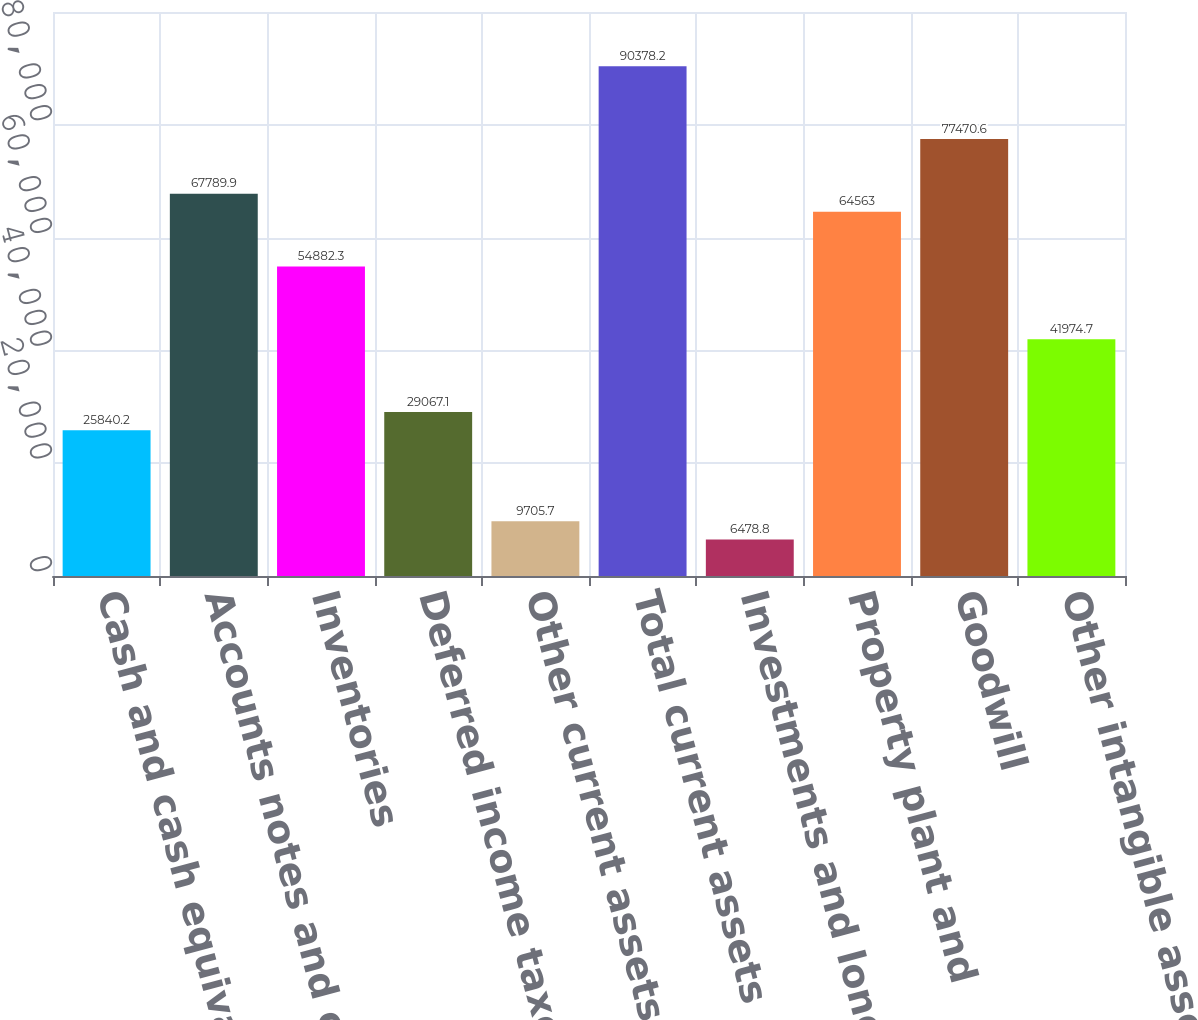<chart> <loc_0><loc_0><loc_500><loc_500><bar_chart><fcel>Cash and cash equivalents<fcel>Accounts notes and other<fcel>Inventories<fcel>Deferred income taxes<fcel>Other current assets<fcel>Total current assets<fcel>Investments and long-term<fcel>Property plant and<fcel>Goodwill<fcel>Other intangible assets-net<nl><fcel>25840.2<fcel>67789.9<fcel>54882.3<fcel>29067.1<fcel>9705.7<fcel>90378.2<fcel>6478.8<fcel>64563<fcel>77470.6<fcel>41974.7<nl></chart> 